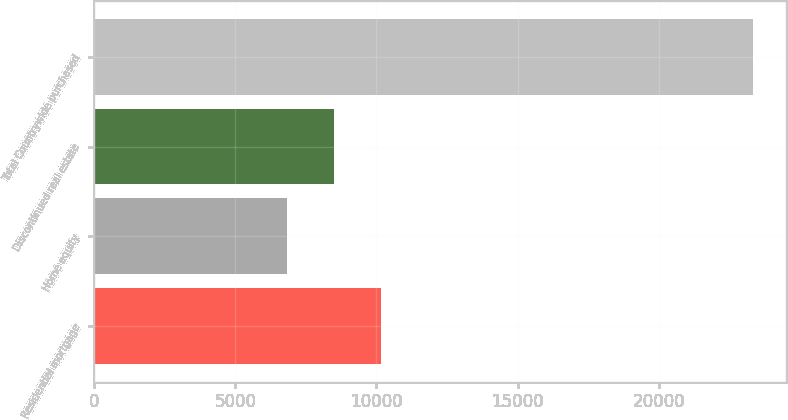Convert chart to OTSL. <chart><loc_0><loc_0><loc_500><loc_500><bar_chart><fcel>Residential mortgage<fcel>Home equity<fcel>Discontinued real estate<fcel>Total Countrywide purchased<nl><fcel>10147.6<fcel>6849<fcel>8498.3<fcel>23342<nl></chart> 